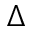Convert formula to latex. <formula><loc_0><loc_0><loc_500><loc_500>\Delta</formula> 